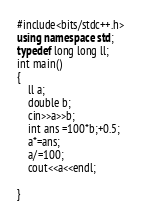Convert code to text. <code><loc_0><loc_0><loc_500><loc_500><_C++_>#include<bits/stdc++.h>
using namespace std;
typedef long long ll;
int main()
{
    ll a;
    double b;
    cin>>a>>b;
    int ans =100*b;+0.5;
    a*=ans;
    a/=100;
    cout<<a<<endl;

}</code> 